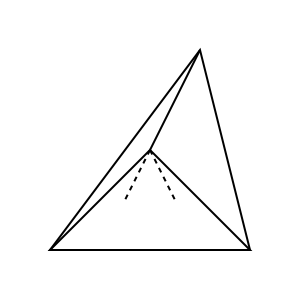Given the partially obscured polyhedron shown in the figure, determine the total number of faces in the complete solid. Assume that all hidden edges are straight lines and the solid is convex. To determine the number of faces in this partially obscured polyhedron, let's analyze the visible features and deduce the hidden structure:

1. Visible faces:
   - We can clearly see 3 triangular faces.

2. Hidden faces:
   - The dashed lines suggest there are hidden edges converging to a point below the visible structure.
   - This implies there's at least one more triangular face at the bottom.

3. Deducing the shape:
   - The visible structure resembles the upper part of a tetrahedron (triangular pyramid).
   - A tetrahedron is the simplest 3D shape that satisfies the visible features and hidden structure.

4. Properties of a tetrahedron:
   - A tetrahedron has 4 triangular faces.
   - It's the simplest convex polyhedron.

5. Confirmation:
   - The visible structure shows 3 faces converging at the top vertex.
   - The dashed lines suggest the 4th face at the bottom.
   - This is consistent with the properties of a tetrahedron.

Therefore, we can conclude that the complete solid is most likely a tetrahedron with 4 faces.
Answer: 4 faces 